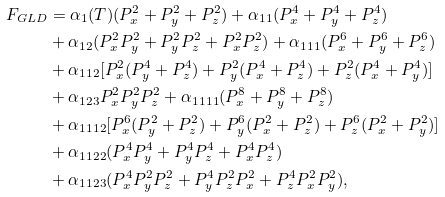<formula> <loc_0><loc_0><loc_500><loc_500>F _ { G L D } & = \alpha _ { 1 } ( T ) ( P _ { x } ^ { 2 } + P _ { y } ^ { 2 } + P _ { z } ^ { 2 } ) + \alpha _ { 1 1 } ( P _ { x } ^ { 4 } + P _ { y } ^ { 4 } + P _ { z } ^ { 4 } ) \\ & + \alpha _ { 1 2 } ( P _ { x } ^ { 2 } P _ { y } ^ { 2 } + P _ { y } ^ { 2 } P _ { z } ^ { 2 } + P _ { x } ^ { 2 } P _ { z } ^ { 2 } ) + \alpha _ { 1 1 1 } ( P _ { x } ^ { 6 } + P _ { y } ^ { 6 } + P _ { z } ^ { 6 } ) \\ & + \alpha _ { 1 1 2 } [ P _ { x } ^ { 2 } ( P _ { y } ^ { 4 } + P _ { z } ^ { 4 } ) + P _ { y } ^ { 2 } ( P _ { x } ^ { 4 } + P _ { z } ^ { 4 } ) + P _ { z } ^ { 2 } ( P _ { x } ^ { 4 } + P _ { y } ^ { 4 } ) ] \\ & + \alpha _ { 1 2 3 } P _ { x } ^ { 2 } P _ { y } ^ { 2 } P _ { z } ^ { 2 } + \alpha _ { 1 1 1 1 } ( P _ { x } ^ { 8 } + P _ { y } ^ { 8 } + P _ { z } ^ { 8 } ) \\ & + \alpha _ { 1 1 1 2 } [ P _ { x } ^ { 6 } ( P _ { y } ^ { 2 } + P _ { z } ^ { 2 } ) + P _ { y } ^ { 6 } ( P _ { x } ^ { 2 } + P _ { z } ^ { 2 } ) + P _ { z } ^ { 6 } ( P _ { x } ^ { 2 } + P _ { y } ^ { 2 } ) ] \\ & + \alpha _ { 1 1 2 2 } ( P _ { x } ^ { 4 } P _ { y } ^ { 4 } + P _ { y } ^ { 4 } P _ { z } ^ { 4 } + P _ { x } ^ { 4 } P _ { z } ^ { 4 } ) \\ & + \alpha _ { 1 1 2 3 } ( P _ { x } ^ { 4 } P _ { y } ^ { 2 } P _ { z } ^ { 2 } + P _ { y } ^ { 4 } P _ { z } ^ { 2 } P _ { x } ^ { 2 } + P _ { z } ^ { 4 } P _ { x } ^ { 2 } P _ { y } ^ { 2 } ) ,</formula> 